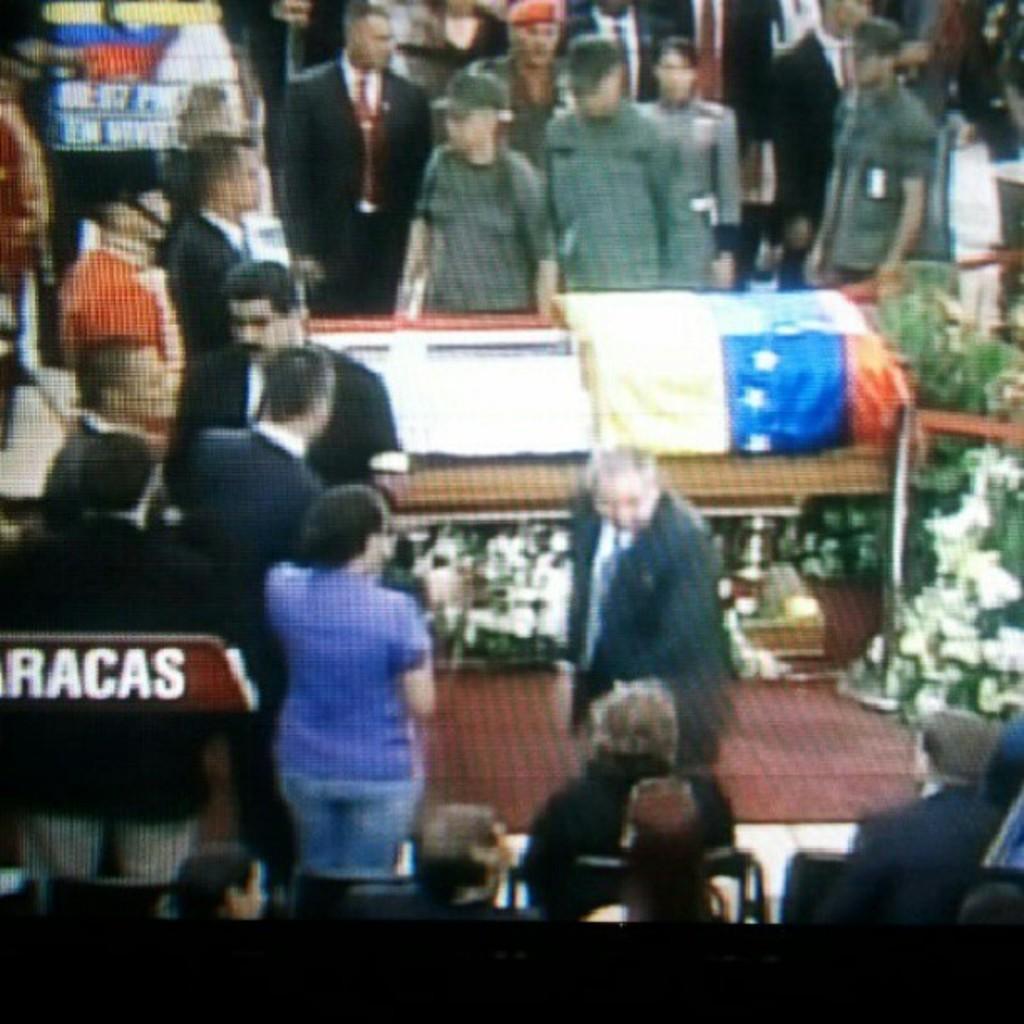How would you summarize this image in a sentence or two? In the picture we can see a video image of some people are standing and some are walking and they are in blazers, ties and shirts and some are in other uniforms. 